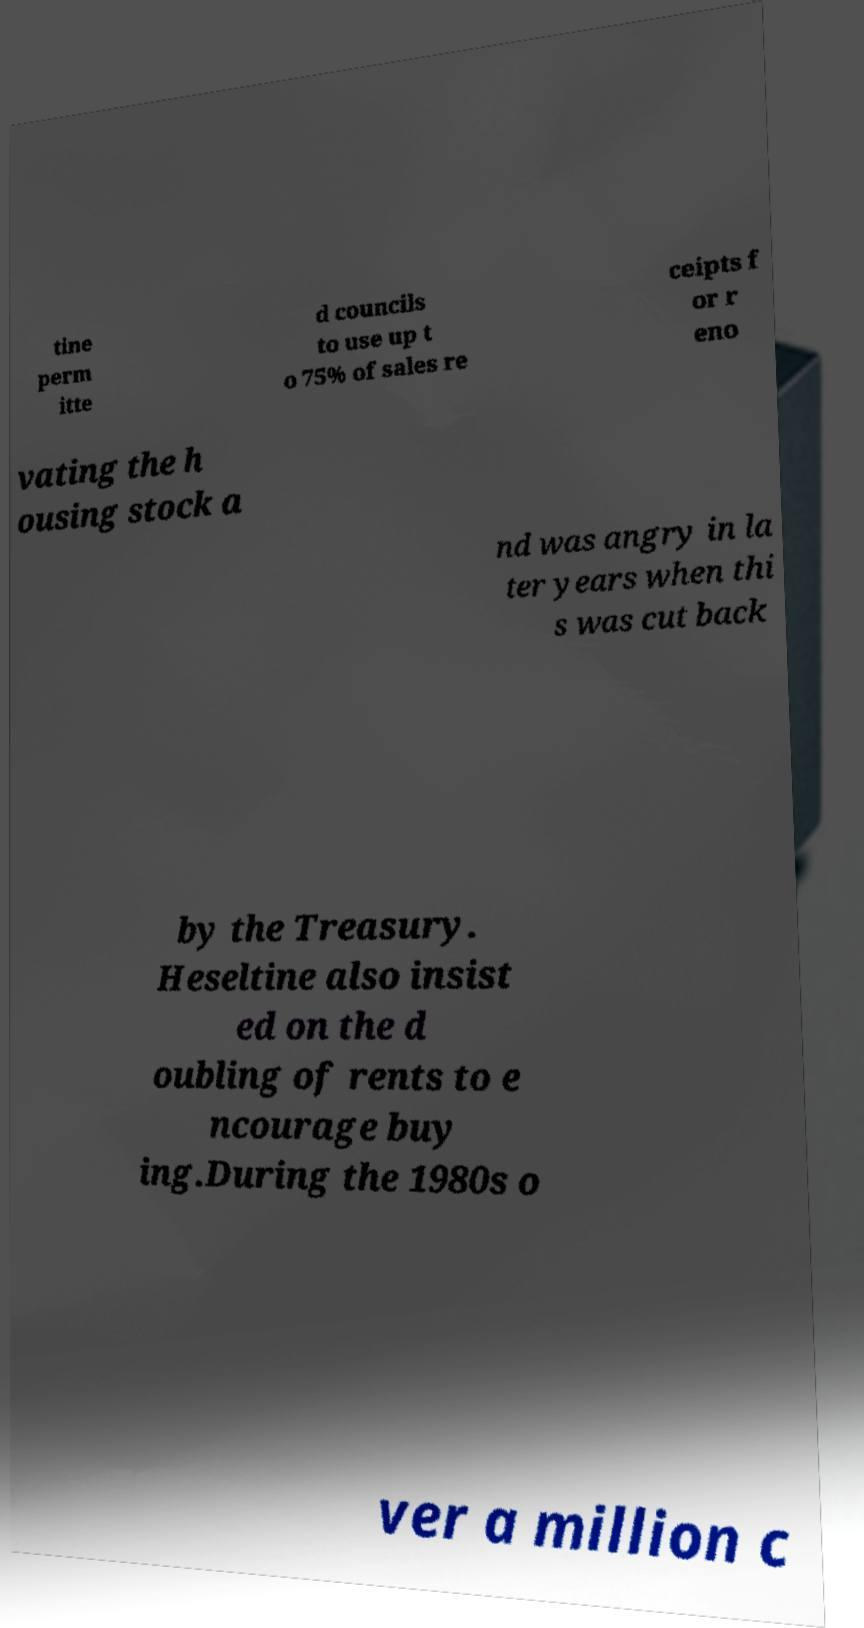What messages or text are displayed in this image? I need them in a readable, typed format. tine perm itte d councils to use up t o 75% of sales re ceipts f or r eno vating the h ousing stock a nd was angry in la ter years when thi s was cut back by the Treasury. Heseltine also insist ed on the d oubling of rents to e ncourage buy ing.During the 1980s o ver a million c 